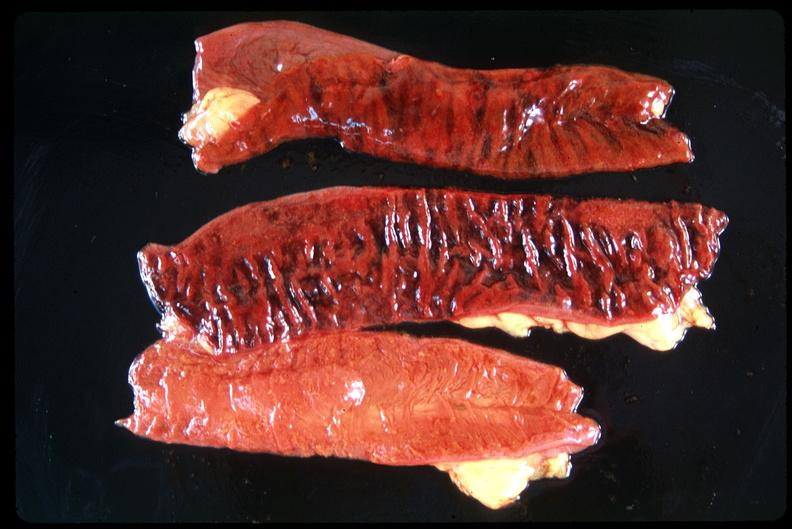does adenocarcinoma show small intestine, ischemic bowel?
Answer the question using a single word or phrase. No 